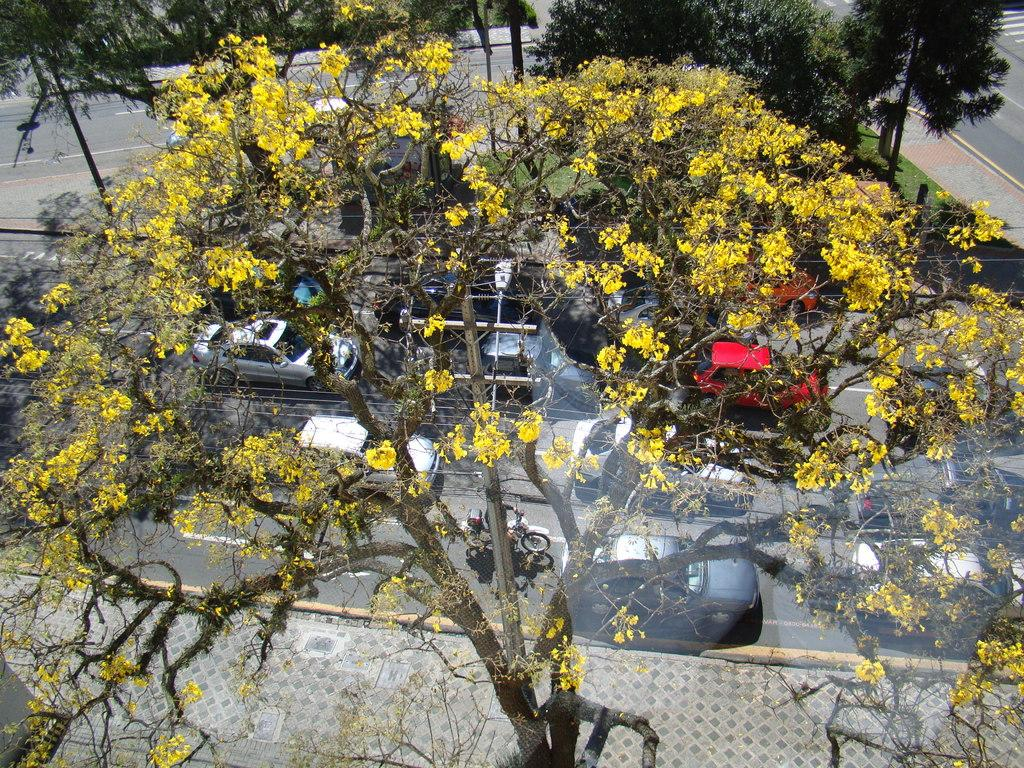What can be seen on the road in the image? There are vehicles on the road in the image. What type of natural elements are visible in the image? There are trees visible in the image. What type of surface is present in the image? There is a pavement in the image. Can you see a kitty wearing a scarf in the image? No, there is no kitty or scarf present in the image. Are there any ghosts visible in the image? No, there are no ghosts present in the image. 